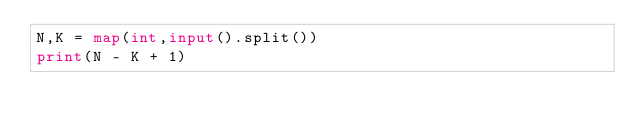<code> <loc_0><loc_0><loc_500><loc_500><_Python_>N,K = map(int,input().split())
print(N - K + 1)</code> 